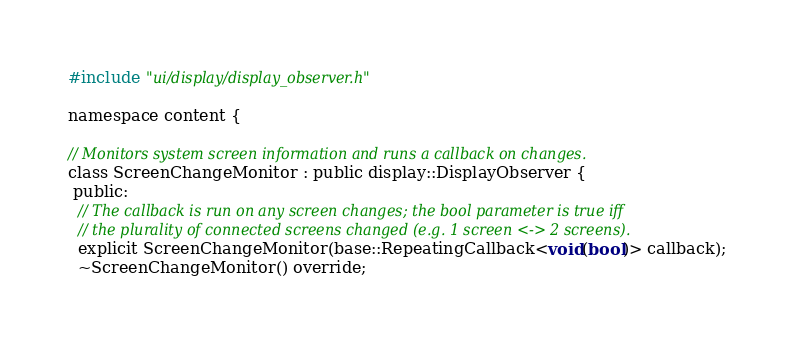<code> <loc_0><loc_0><loc_500><loc_500><_C_>#include "ui/display/display_observer.h"

namespace content {

// Monitors system screen information and runs a callback on changes.
class ScreenChangeMonitor : public display::DisplayObserver {
 public:
  // The callback is run on any screen changes; the bool parameter is true iff
  // the plurality of connected screens changed (e.g. 1 screen <-> 2 screens).
  explicit ScreenChangeMonitor(base::RepeatingCallback<void(bool)> callback);
  ~ScreenChangeMonitor() override;
</code> 